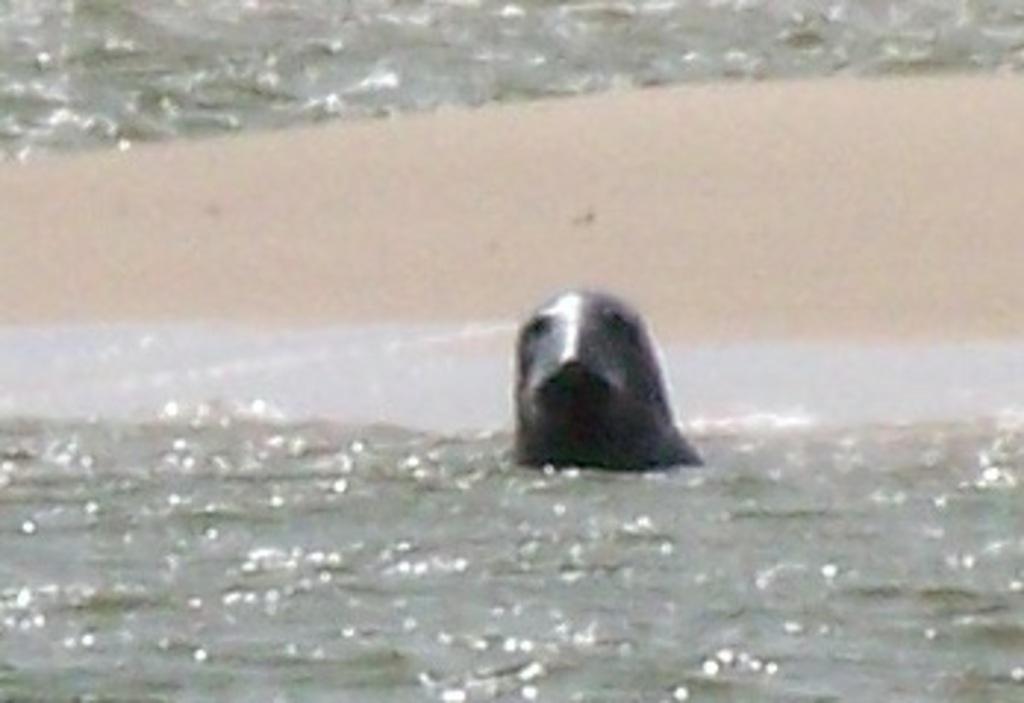Can you describe this image briefly? In this picture there is a seal in the center of the image in the water. 